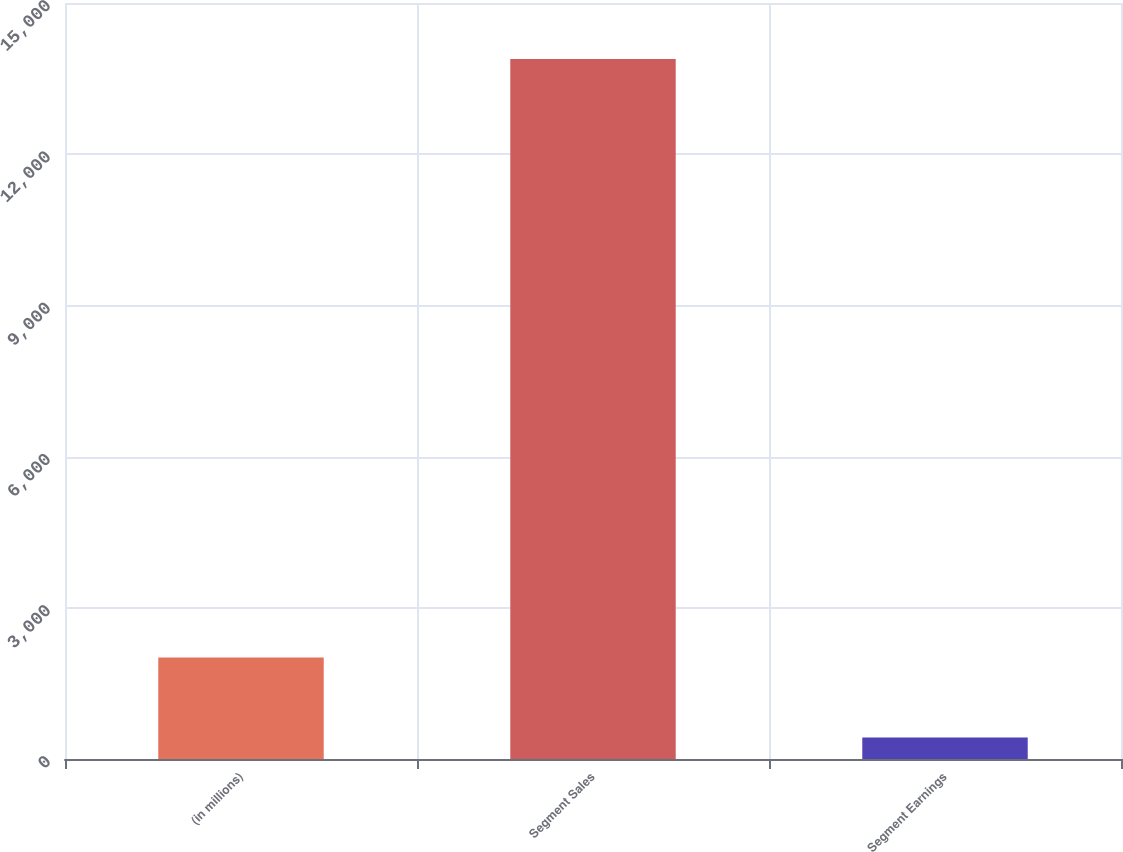Convert chart. <chart><loc_0><loc_0><loc_500><loc_500><bar_chart><fcel>(in millions)<fcel>Segment Sales<fcel>Segment Earnings<nl><fcel>2014<fcel>13887<fcel>428<nl></chart> 